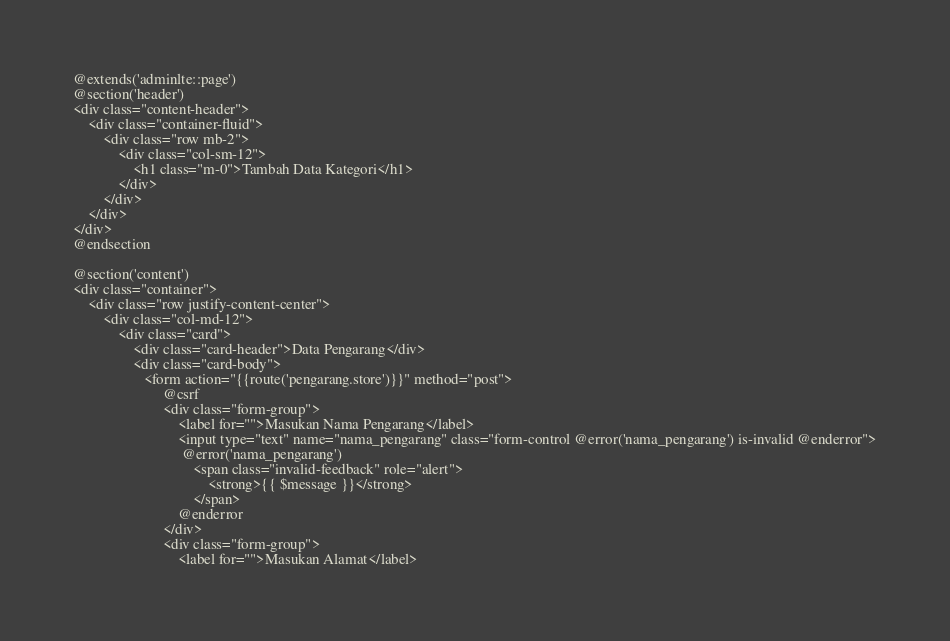Convert code to text. <code><loc_0><loc_0><loc_500><loc_500><_PHP_>@extends('adminlte::page')
@section('header')
<div class="content-header">
    <div class="container-fluid">
        <div class="row mb-2">
            <div class="col-sm-12">
                <h1 class="m-0">Tambah Data Kategori</h1>
            </div>
        </div>
    </div>
</div>
@endsection

@section('content')
<div class="container">
    <div class="row justify-content-center">
        <div class="col-md-12">
            <div class="card">
                <div class="card-header">Data Pengarang</div>
                <div class="card-body">
                   <form action="{{route('pengarang.store')}}" method="post">
                        @csrf
                        <div class="form-group">
                            <label for="">Masukan Nama Pengarang</label>
                            <input type="text" name="nama_pengarang" class="form-control @error('nama_pengarang') is-invalid @enderror">
                             @error('nama_pengarang')
                                <span class="invalid-feedback" role="alert">
                                    <strong>{{ $message }}</strong>
                                </span>
                            @enderror
                        </div>
                        <div class="form-group">
                            <label for="">Masukan Alamat</label></code> 